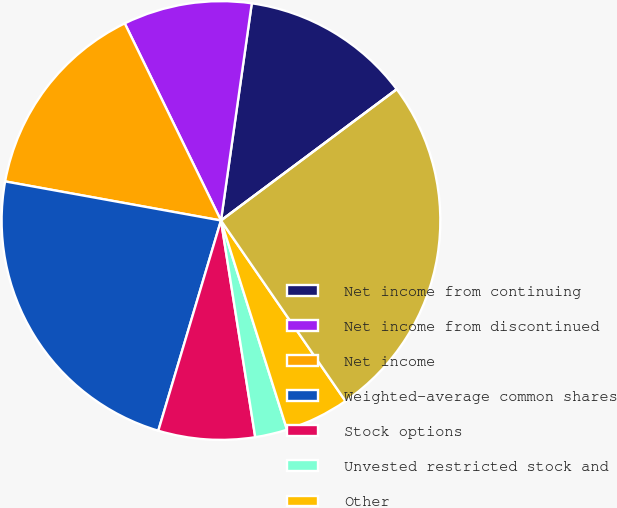Convert chart to OTSL. <chart><loc_0><loc_0><loc_500><loc_500><pie_chart><fcel>Net income from continuing<fcel>Net income from discontinued<fcel>Net income<fcel>Weighted-average common shares<fcel>Stock options<fcel>Unvested restricted stock and<fcel>Other<fcel>Shares used to compute diluted<fcel>Net Income<nl><fcel>12.55%<fcel>9.47%<fcel>14.92%<fcel>23.24%<fcel>7.11%<fcel>2.37%<fcel>4.74%<fcel>25.6%<fcel>0.0%<nl></chart> 